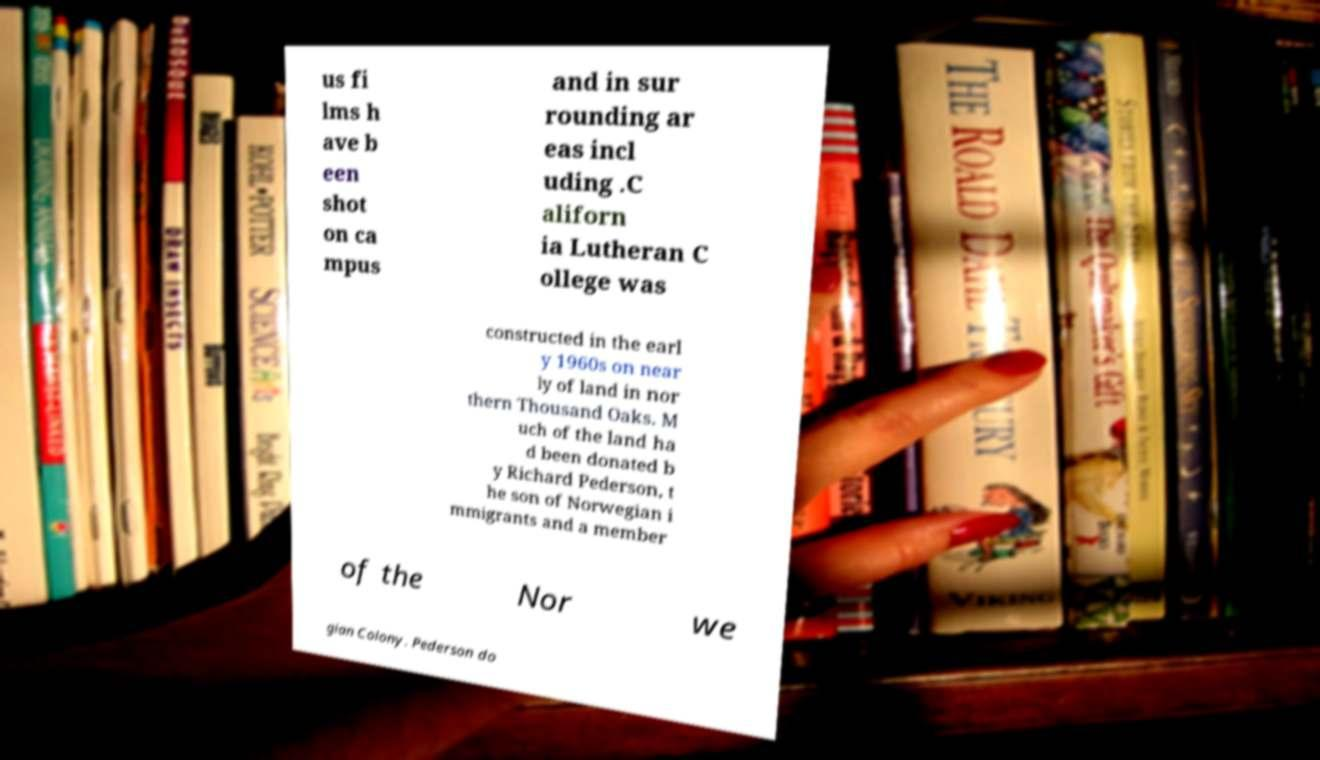Could you assist in decoding the text presented in this image and type it out clearly? us fi lms h ave b een shot on ca mpus and in sur rounding ar eas incl uding .C aliforn ia Lutheran C ollege was constructed in the earl y 1960s on near ly of land in nor thern Thousand Oaks. M uch of the land ha d been donated b y Richard Pederson, t he son of Norwegian i mmigrants and a member of the Nor we gian Colony. Pederson do 